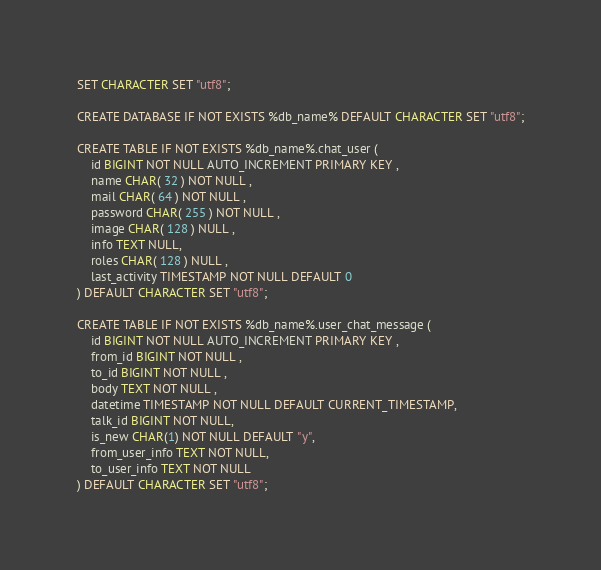Convert code to text. <code><loc_0><loc_0><loc_500><loc_500><_SQL_>SET CHARACTER SET "utf8";

CREATE DATABASE IF NOT EXISTS %db_name% DEFAULT CHARACTER SET "utf8";

CREATE TABLE IF NOT EXISTS %db_name%.chat_user (
    id BIGINT NOT NULL AUTO_INCREMENT PRIMARY KEY ,
    name CHAR( 32 ) NOT NULL ,
    mail CHAR( 64 ) NOT NULL ,
    password CHAR( 255 ) NOT NULL ,
    image CHAR( 128 ) NULL ,
    info TEXT NULL,
    roles CHAR( 128 ) NULL ,
    last_activity TIMESTAMP NOT NULL DEFAULT 0
) DEFAULT CHARACTER SET "utf8";

CREATE TABLE IF NOT EXISTS %db_name%.user_chat_message (
    id BIGINT NOT NULL AUTO_INCREMENT PRIMARY KEY ,
    from_id BIGINT NOT NULL ,
    to_id BIGINT NOT NULL ,
    body TEXT NOT NULL ,
    datetime TIMESTAMP NOT NULL DEFAULT CURRENT_TIMESTAMP,
    talk_id BIGINT NOT NULL,
    is_new CHAR(1) NOT NULL DEFAULT "y",
    from_user_info TEXT NOT NULL,
    to_user_info TEXT NOT NULL
) DEFAULT CHARACTER SET "utf8";</code> 